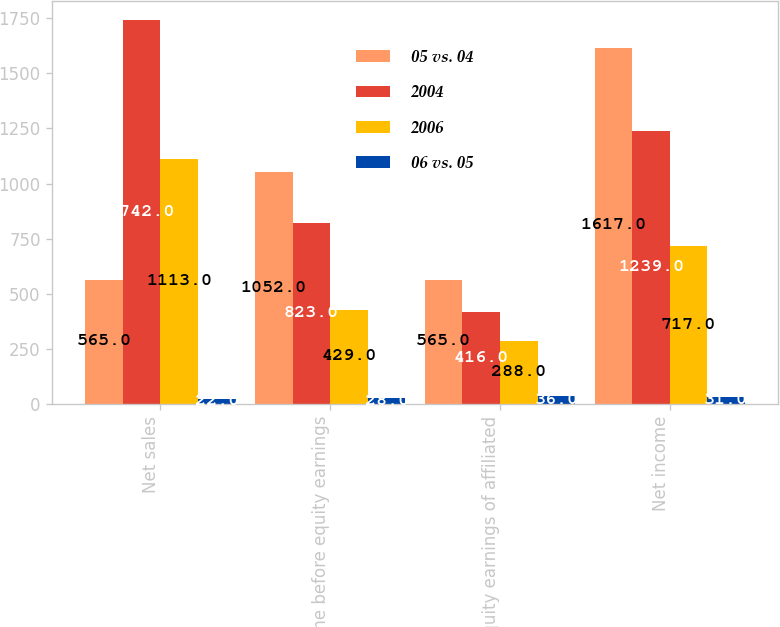Convert chart to OTSL. <chart><loc_0><loc_0><loc_500><loc_500><stacked_bar_chart><ecel><fcel>Net sales<fcel>Income before equity earnings<fcel>Equity earnings of affiliated<fcel>Net income<nl><fcel>05 vs. 04<fcel>565<fcel>1052<fcel>565<fcel>1617<nl><fcel>2004<fcel>1742<fcel>823<fcel>416<fcel>1239<nl><fcel>2006<fcel>1113<fcel>429<fcel>288<fcel>717<nl><fcel>06 vs. 05<fcel>22<fcel>28<fcel>36<fcel>31<nl></chart> 